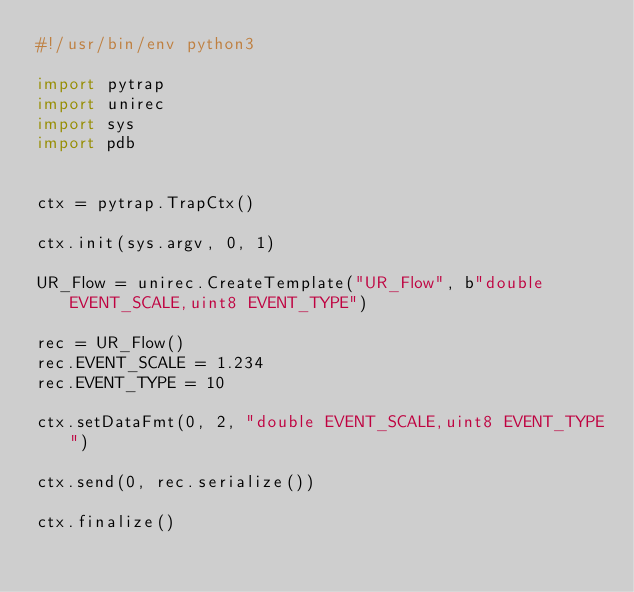<code> <loc_0><loc_0><loc_500><loc_500><_Python_>#!/usr/bin/env python3

import pytrap
import unirec
import sys
import pdb


ctx = pytrap.TrapCtx()

ctx.init(sys.argv, 0, 1)

UR_Flow = unirec.CreateTemplate("UR_Flow", b"double EVENT_SCALE,uint8 EVENT_TYPE")

rec = UR_Flow()
rec.EVENT_SCALE = 1.234
rec.EVENT_TYPE = 10

ctx.setDataFmt(0, 2, "double EVENT_SCALE,uint8 EVENT_TYPE")

ctx.send(0, rec.serialize())

ctx.finalize()



</code> 